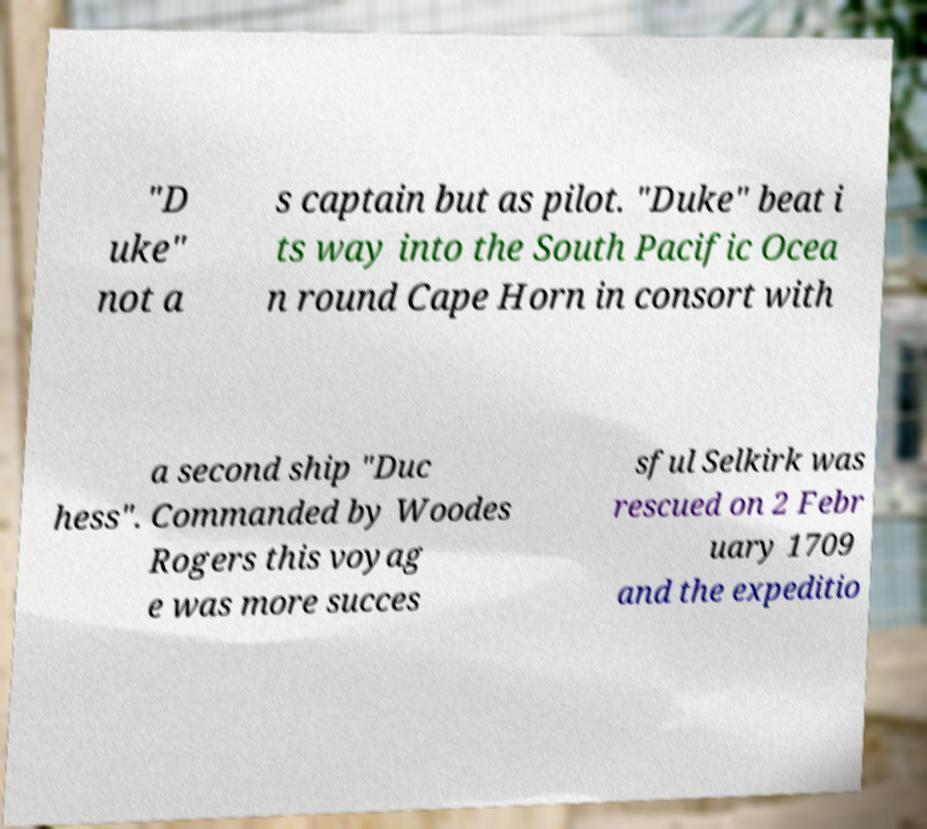There's text embedded in this image that I need extracted. Can you transcribe it verbatim? "D uke" not a s captain but as pilot. "Duke" beat i ts way into the South Pacific Ocea n round Cape Horn in consort with a second ship "Duc hess". Commanded by Woodes Rogers this voyag e was more succes sful Selkirk was rescued on 2 Febr uary 1709 and the expeditio 